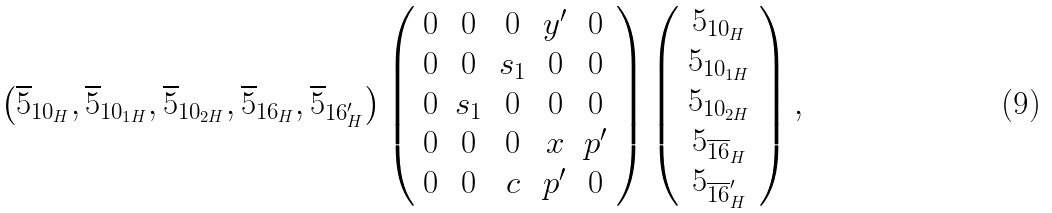<formula> <loc_0><loc_0><loc_500><loc_500>\left ( \overline { 5 } _ { 1 0 _ { H } } , \overline { 5 } _ { 1 0 _ { 1 H } } , \overline { 5 } _ { 1 0 _ { 2 H } } , \overline { 5 } _ { 1 6 _ { H } } , \overline { 5 } _ { 1 6 ^ { \prime } _ { H } } \right ) \left ( \begin{array} { c c c c c } 0 & 0 & 0 & y ^ { \prime } & 0 \\ 0 & 0 & s _ { 1 } & 0 & 0 \\ 0 & s _ { 1 } & 0 & 0 & 0 \\ 0 & 0 & 0 & x & p ^ { \prime } \\ 0 & 0 & c & p ^ { \prime } & 0 \end{array} \right ) \left ( \begin{array} { c } { 5 } _ { 1 0 _ { H } } \\ { 5 } _ { 1 0 _ { 1 H } } \\ { 5 } _ { 1 0 _ { 2 H } } \\ { 5 } _ { \overline { 1 6 } _ { H } } \\ { 5 } _ { \overline { 1 6 } ^ { \prime } _ { H } } \end{array} \right ) ,</formula> 